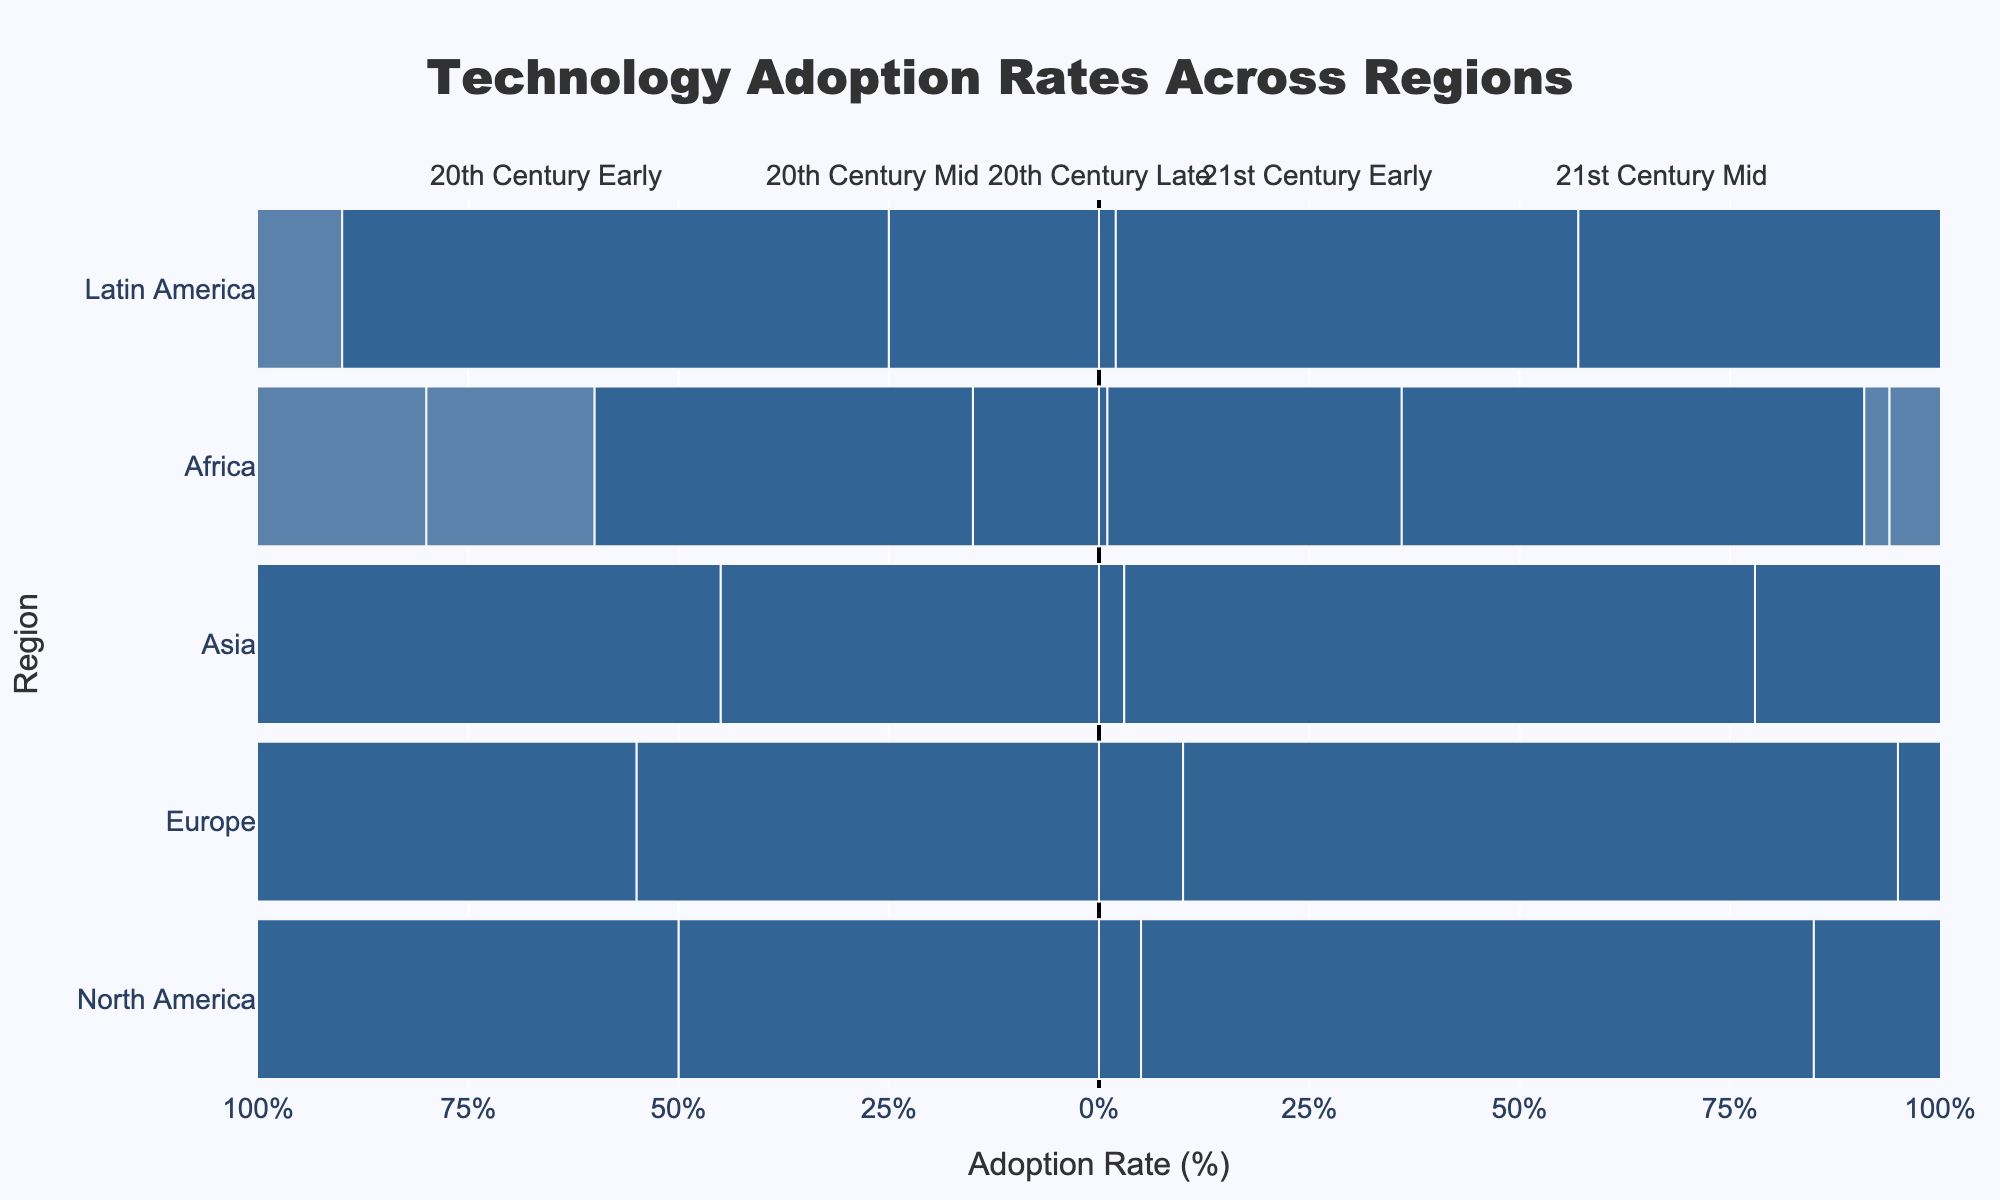What's the 21st Century Early AI Technology adoption rate in Asia? Observe the 21st Century Early Adoption Rate for AI Technology in the Asia bar segment.
Answer: 18% Which region had the highest adoption rate of mobile phones in the 20th Century Late period? Compare the 20th Century Late Adoption Rate for mobile phones across all regions. North America had the highest at 25%.
Answer: North America How does the 21st Century Mid adoption rate of electricity compare between Europe and Africa? Look at the 21st Century Mid Adoption Rate (%) bars for electricity for both Europe and Africa. Europe has 98%, and Africa has 55%. Therefore, Europe is higher.
Answer: Europe Which technology had the smallest adoption rate in North America during the 21st Century Early period? Check the 21st Century Early Adoption Rate for all technologies in North America. AI Technology has the smallest adoption rate at 20%.
Answer: AI Technology What is the median 20th Century Early adoption rate for the Internet across all regions? List the 20th Century Early Adoption Rate for the Internet for all regions, which are 0, then find the median. Since all values are zero, the median is zero.
Answer: 0 How much greater is the 21st Century Mid adoption of Internet in Europe compared to Africa? Find the 21st Century Mid Adoption Rate for the Internet for both Europe (92%) and Africa (50%), then subtract the latter from the former (92% - 50% = 42%).
Answer: 42% What is the average 20th Century Mid adoption rate of telephone in Europe and North America? Sum the 20th Century Mid Adoption Rate (%) of telephone in Europe (45%) and North America (40%), then divide by 2. (45 + 40) / 2 = 42.5%
Answer: 42.5% Which century and region had the highest AI Technology adoption rate? Review the AI Technology adoption rates for all centuries and regions. The highest is 21st Century Mid in Europe at 65%.
Answer: 21st Century Mid in Europe Which region had a higher adoption rate of electricity than mobile phones in the 20th Century Mid period? Compare the 20th Century Mid Adoption Rate of electricity and mobile phones for all regions. North America, Europe, and Latin America had higher rates for electricity than mobile phones.
Answer: North America, Europe, Latin America 